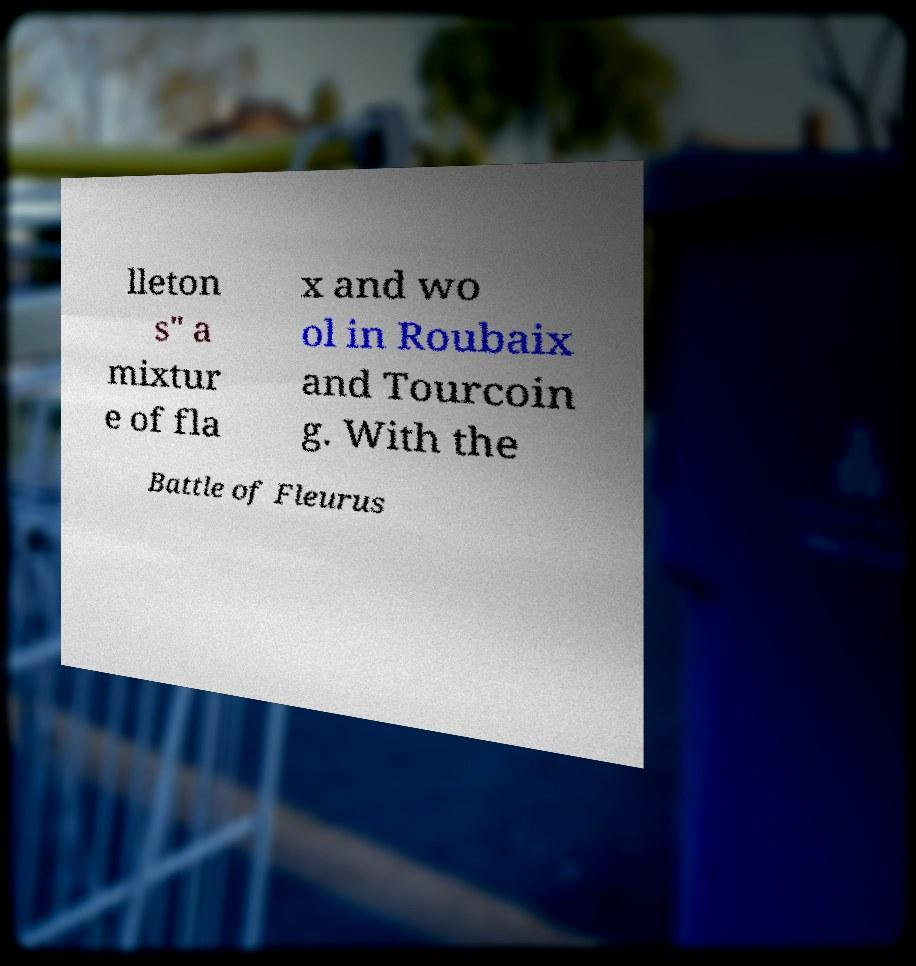Can you accurately transcribe the text from the provided image for me? lleton s" a mixtur e of fla x and wo ol in Roubaix and Tourcoin g. With the Battle of Fleurus 